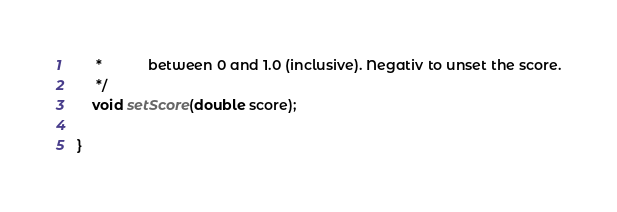<code> <loc_0><loc_0><loc_500><loc_500><_Java_>	 *            between 0 and 1.0 (inclusive). Negativ to unset the score.
	 */
	void setScore(double score);

}
</code> 